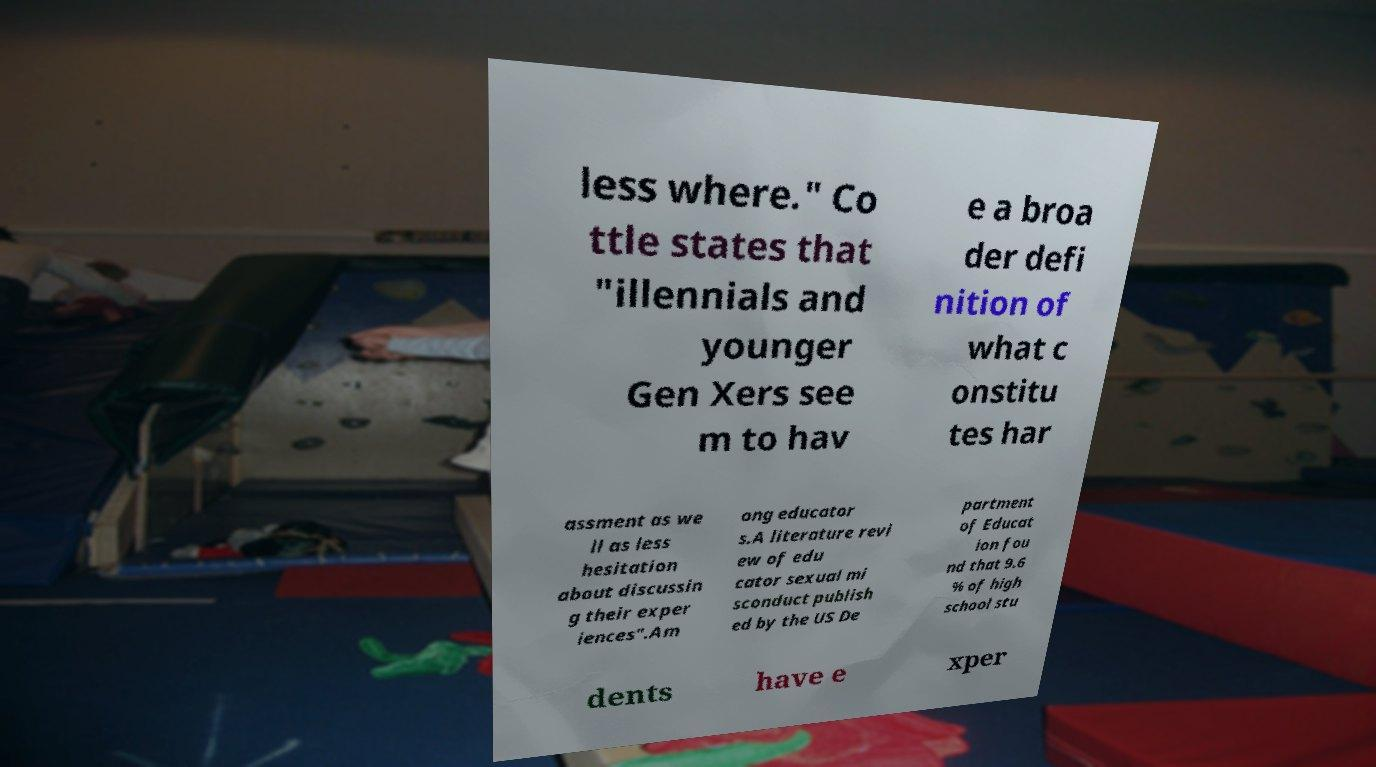Please identify and transcribe the text found in this image. less where." Co ttle states that "illennials and younger Gen Xers see m to hav e a broa der defi nition of what c onstitu tes har assment as we ll as less hesitation about discussin g their exper iences".Am ong educator s.A literature revi ew of edu cator sexual mi sconduct publish ed by the US De partment of Educat ion fou nd that 9.6 % of high school stu dents have e xper 